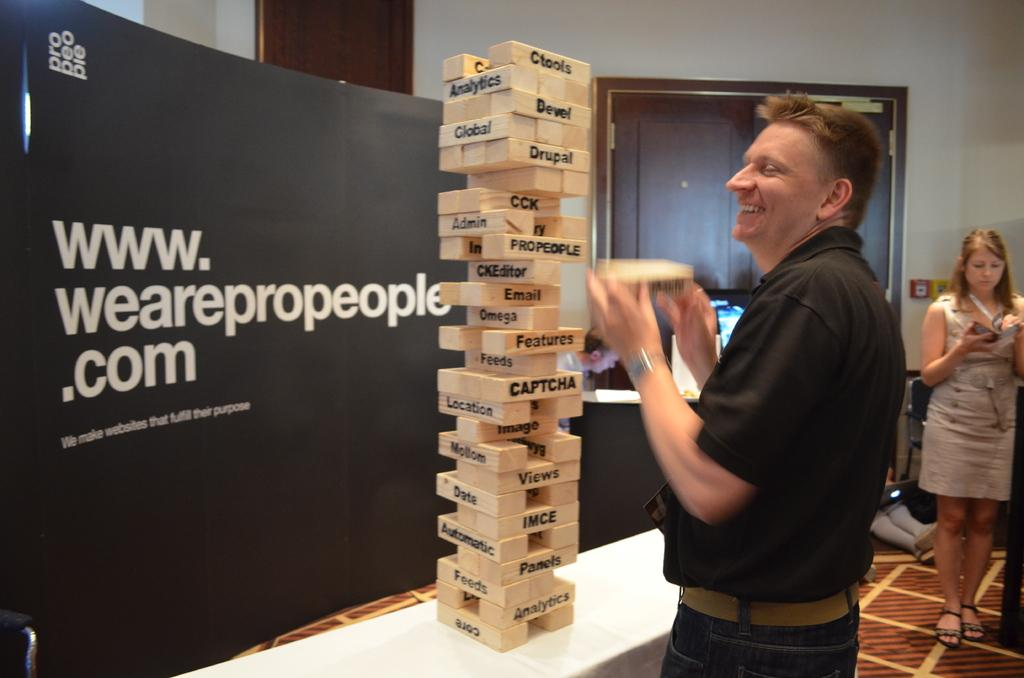<image>
Write a terse but informative summary of the picture. A man plays Jenga with words like Email and Views written on the pieces. 